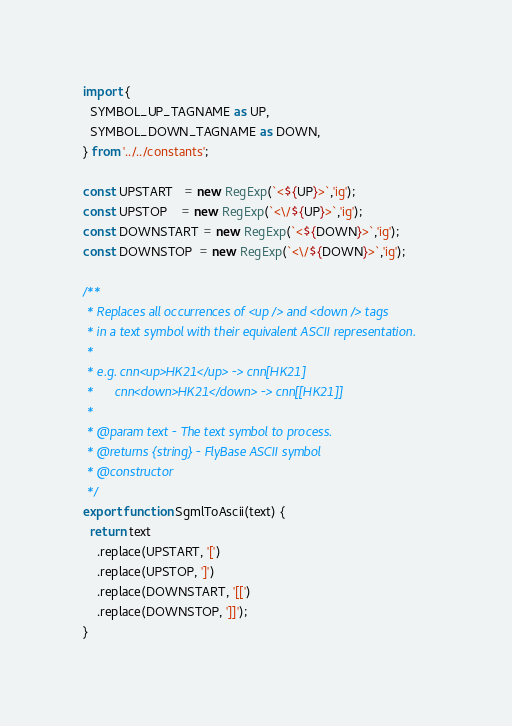<code> <loc_0><loc_0><loc_500><loc_500><_JavaScript_>import {
  SYMBOL_UP_TAGNAME as UP,
  SYMBOL_DOWN_TAGNAME as DOWN,
} from '../../constants';

const UPSTART   = new RegExp(`<${UP}>`,'ig');
const UPSTOP    = new RegExp(`<\/${UP}>`,'ig');
const DOWNSTART = new RegExp(`<${DOWN}>`,'ig');
const DOWNSTOP  = new RegExp(`<\/${DOWN}>`,'ig');

/**
 * Replaces all occurrences of <up /> and <down /> tags
 * in a text symbol with their equivalent ASCII representation.
 *
 * e.g. cnn<up>HK21</up> -> cnn[HK21]
 *      cnn<down>HK21</down> -> cnn[[HK21]]
 *
 * @param text - The text symbol to process.
 * @returns {string} - FlyBase ASCII symbol
 * @constructor
 */
export function SgmlToAscii(text) {
  return text
    .replace(UPSTART, '[')
    .replace(UPSTOP, ']')
    .replace(DOWNSTART, '[[')
    .replace(DOWNSTOP, ']]');
}</code> 